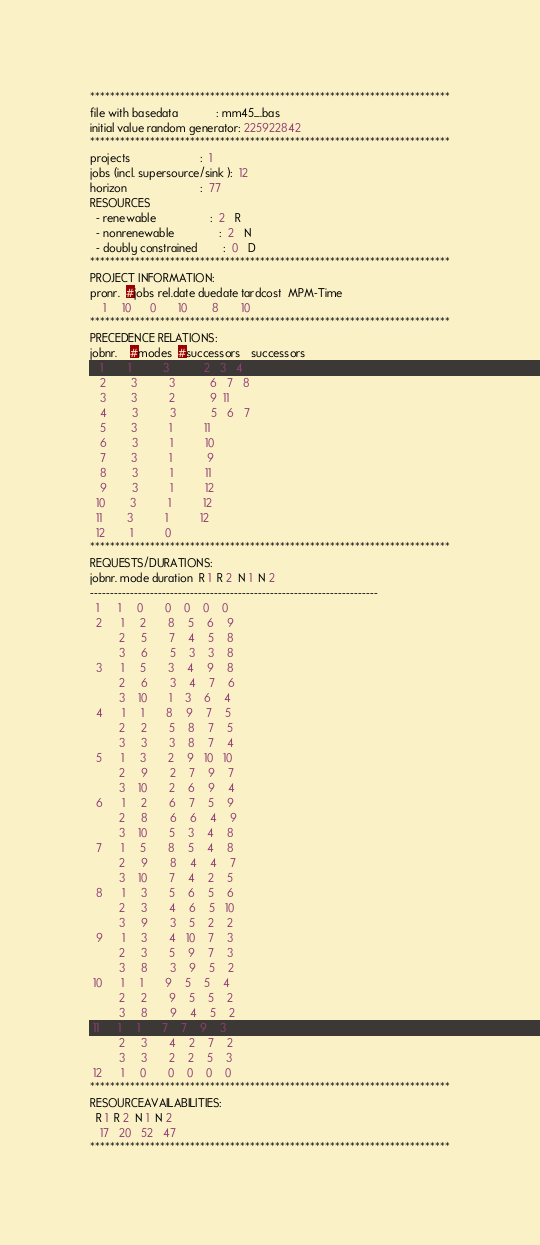Convert code to text. <code><loc_0><loc_0><loc_500><loc_500><_ObjectiveC_>************************************************************************
file with basedata            : mm45_.bas
initial value random generator: 225922842
************************************************************************
projects                      :  1
jobs (incl. supersource/sink ):  12
horizon                       :  77
RESOURCES
  - renewable                 :  2   R
  - nonrenewable              :  2   N
  - doubly constrained        :  0   D
************************************************************************
PROJECT INFORMATION:
pronr.  #jobs rel.date duedate tardcost  MPM-Time
    1     10      0       10        8       10
************************************************************************
PRECEDENCE RELATIONS:
jobnr.    #modes  #successors   successors
   1        1          3           2   3   4
   2        3          3           6   7   8
   3        3          2           9  11
   4        3          3           5   6   7
   5        3          1          11
   6        3          1          10
   7        3          1           9
   8        3          1          11
   9        3          1          12
  10        3          1          12
  11        3          1          12
  12        1          0        
************************************************************************
REQUESTS/DURATIONS:
jobnr. mode duration  R 1  R 2  N 1  N 2
------------------------------------------------------------------------
  1      1     0       0    0    0    0
  2      1     2       8    5    6    9
         2     5       7    4    5    8
         3     6       5    3    3    8
  3      1     5       3    4    9    8
         2     6       3    4    7    6
         3    10       1    3    6    4
  4      1     1       8    9    7    5
         2     2       5    8    7    5
         3     3       3    8    7    4
  5      1     3       2    9   10   10
         2     9       2    7    9    7
         3    10       2    6    9    4
  6      1     2       6    7    5    9
         2     8       6    6    4    9
         3    10       5    3    4    8
  7      1     5       8    5    4    8
         2     9       8    4    4    7
         3    10       7    4    2    5
  8      1     3       5    6    5    6
         2     3       4    6    5   10
         3     9       3    5    2    2
  9      1     3       4   10    7    3
         2     3       5    9    7    3
         3     8       3    9    5    2
 10      1     1       9    5    5    4
         2     2       9    5    5    2
         3     8       9    4    5    2
 11      1     1       7    7    9    3
         2     3       4    2    7    2
         3     3       2    2    5    3
 12      1     0       0    0    0    0
************************************************************************
RESOURCEAVAILABILITIES:
  R 1  R 2  N 1  N 2
   17   20   52   47
************************************************************************
</code> 